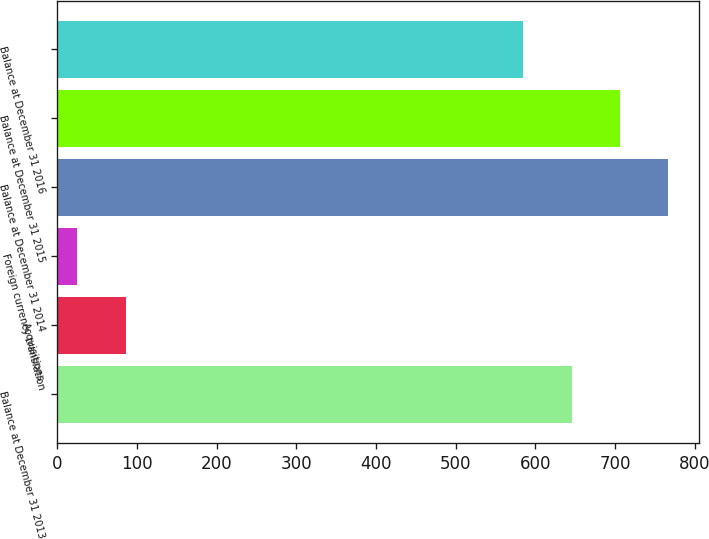Convert chart. <chart><loc_0><loc_0><loc_500><loc_500><bar_chart><fcel>Balance at December 31 2013<fcel>Acquisitions<fcel>Foreign currency translation<fcel>Balance at December 31 2014<fcel>Balance at December 31 2015<fcel>Balance at December 31 2016<nl><fcel>645.7<fcel>85.7<fcel>25<fcel>767.1<fcel>706.4<fcel>585<nl></chart> 